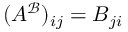Convert formula to latex. <formula><loc_0><loc_0><loc_500><loc_500>( A ^ { \mathcal { B } } ) _ { i j } = B _ { j i }</formula> 